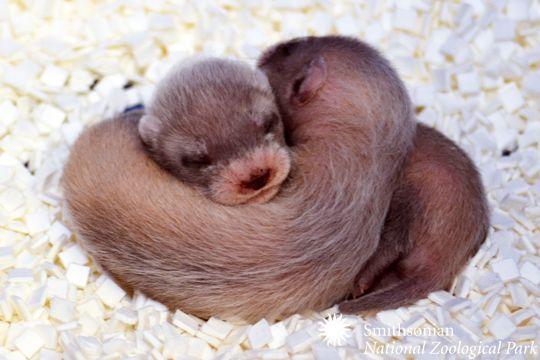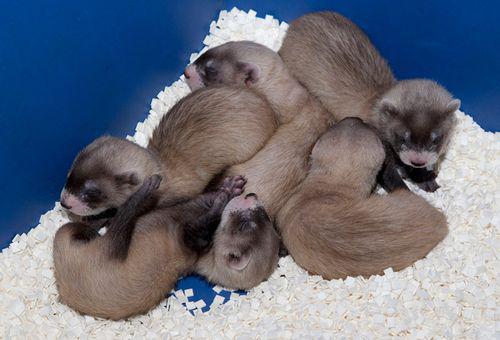The first image is the image on the left, the second image is the image on the right. Considering the images on both sides, is "The left image contains at least two ferrets." valid? Answer yes or no. Yes. The first image is the image on the left, the second image is the image on the right. Examine the images to the left and right. Is the description "At one image shows a group of at least three ferrets inside a brightly colored blue box with white nesting material." accurate? Answer yes or no. Yes. 